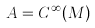Convert formula to latex. <formula><loc_0><loc_0><loc_500><loc_500>A = C ^ { \infty } ( M )</formula> 